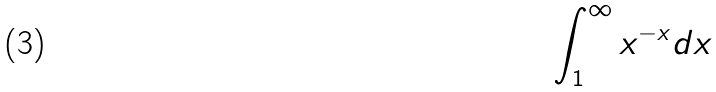<formula> <loc_0><loc_0><loc_500><loc_500>\int _ { 1 } ^ { \infty } x ^ { - x } d x</formula> 